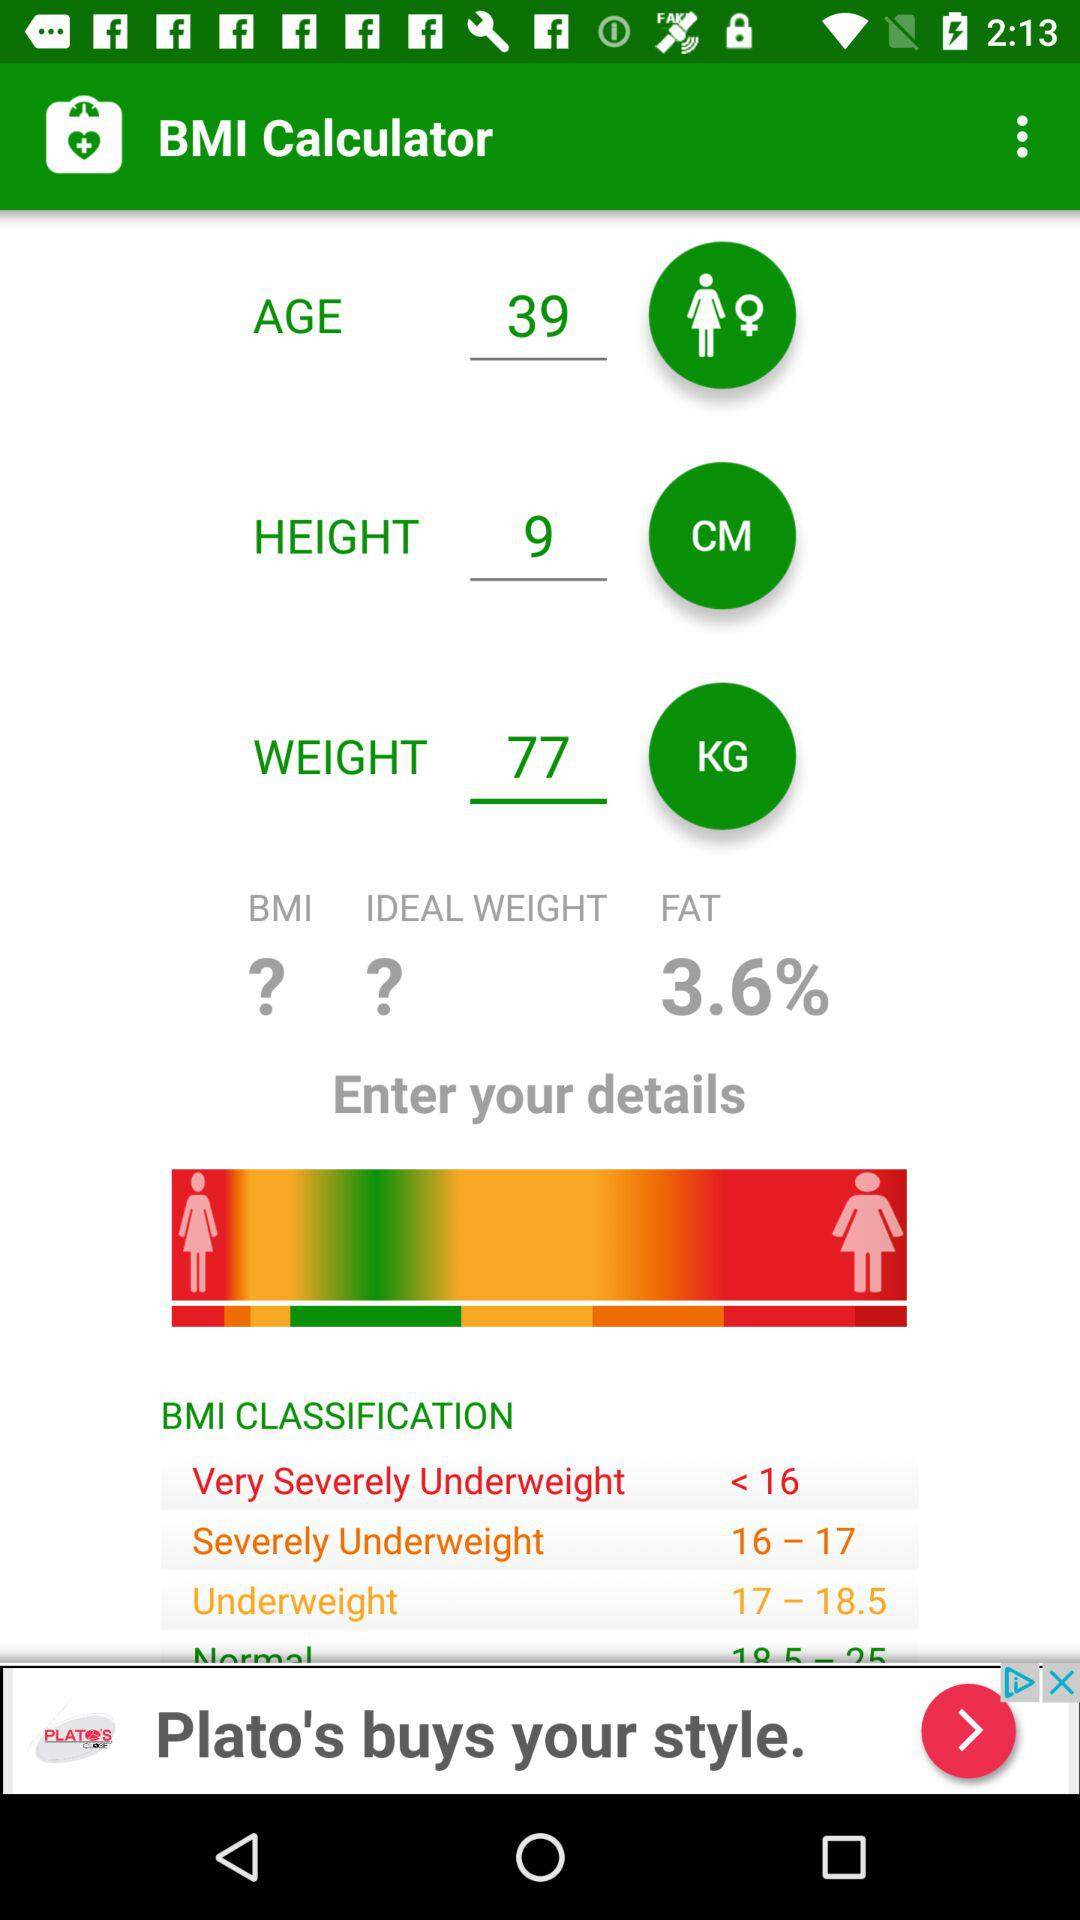What is the age? The age is 39 years. 